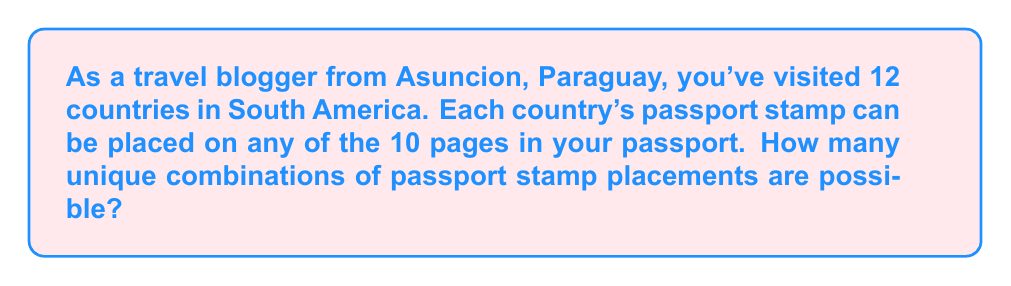Teach me how to tackle this problem. Let's approach this step-by-step:

1) We have 12 stamps (one from each country) and 10 pages to place them on.

2) This is a problem of distributing distinguishable objects (stamps) into distinguishable containers (pages) with repetition allowed.

3) For each stamp, we have 10 choices of pages to place it on.

4) Since the choice for each stamp is independent of the others, we can use the multiplication principle.

5) The total number of ways to place the stamps is:

   $$10 \times 10 \times 10 \times ... \text{ (12 times) } ... \times 10$$

6) This can be written as an exponent:

   $$10^{12}$$

7) Therefore, the number of unique combinations of passport stamp placements is $10^{12}$.
Answer: $10^{12}$ 